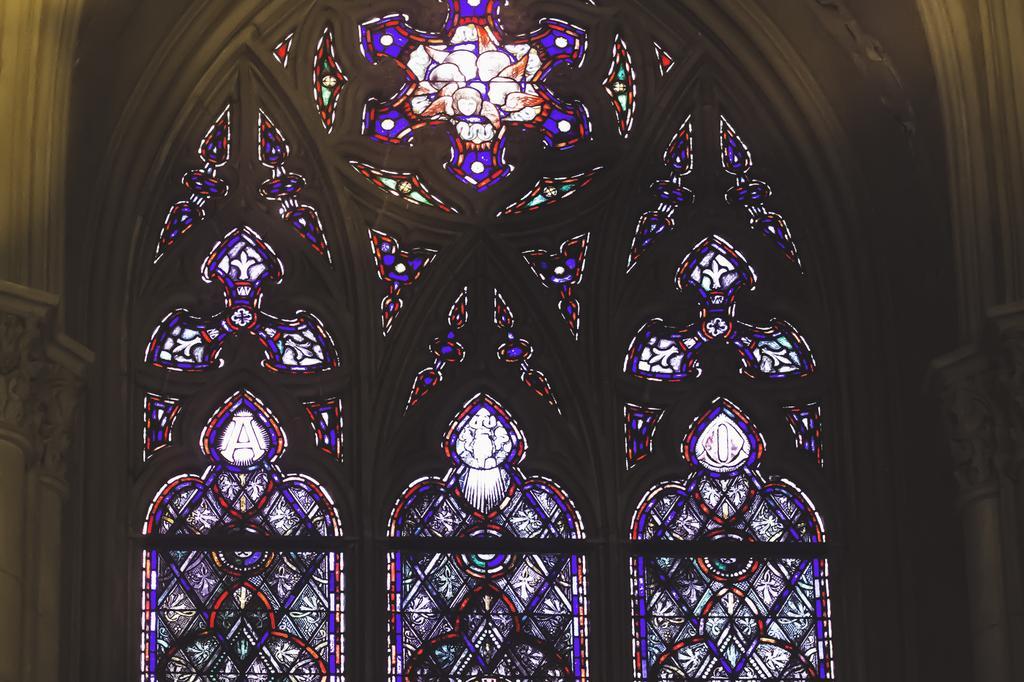Please provide a concise description of this image. This is a wall full of design and the letters on it are A and I. 